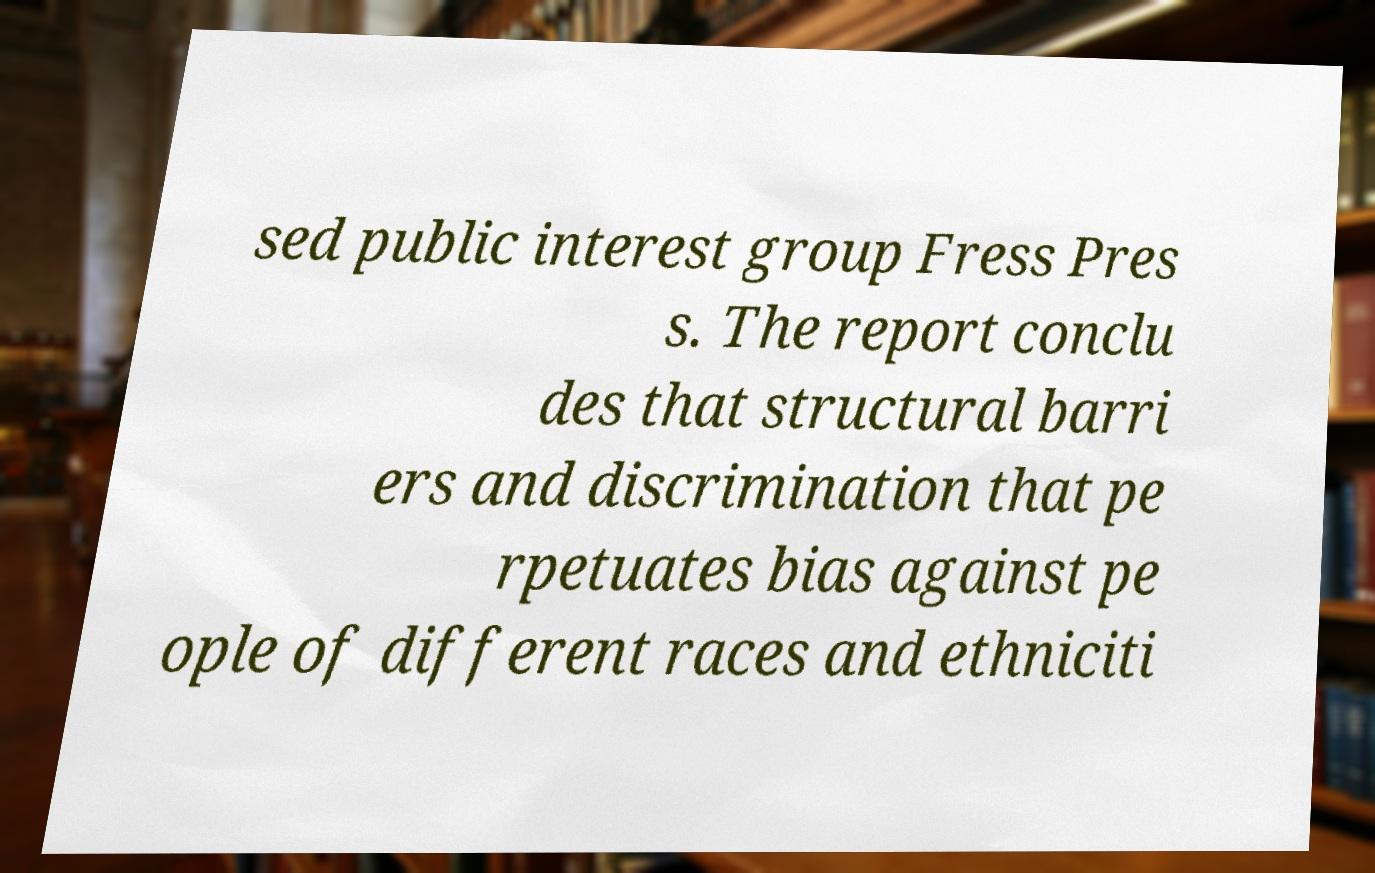There's text embedded in this image that I need extracted. Can you transcribe it verbatim? sed public interest group Fress Pres s. The report conclu des that structural barri ers and discrimination that pe rpetuates bias against pe ople of different races and ethniciti 